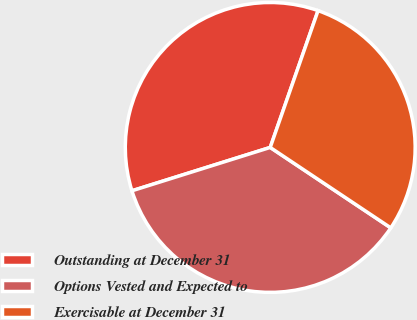Convert chart. <chart><loc_0><loc_0><loc_500><loc_500><pie_chart><fcel>Outstanding at December 31<fcel>Options Vested and Expected to<fcel>Exercisable at December 31<nl><fcel>35.19%<fcel>35.8%<fcel>29.01%<nl></chart> 